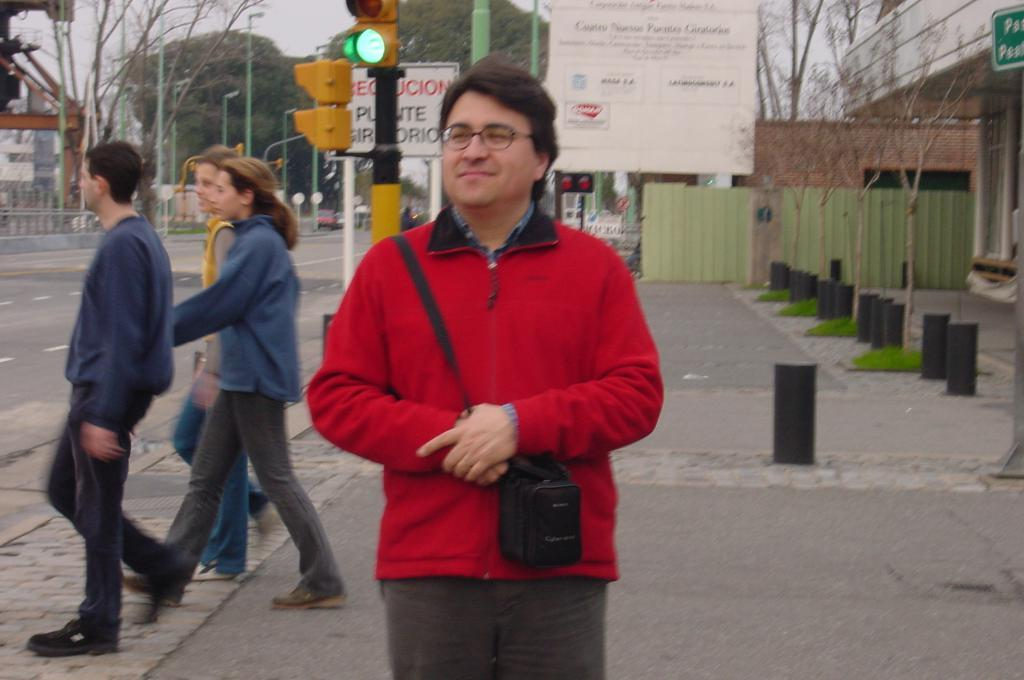What are the people in the image doing? The people in the image are standing on the road. What objects are present to control traffic in the image? Barrier poles, traffic poles, traffic signals, and street poles are present in the image to control traffic. What type of structures can be seen in the background of the image? Buildings are visible in the image. What objects are present to provide illumination in the image? Street lights are present in the image to provide illumination. What type of vegetation is visible in the image? Trees are visible in the image. What part of the natural environment is visible in the image? The sky is visible in the image. How many cent frogs are hopping on the wheel in the image? There are no frogs or wheels present in the image. 